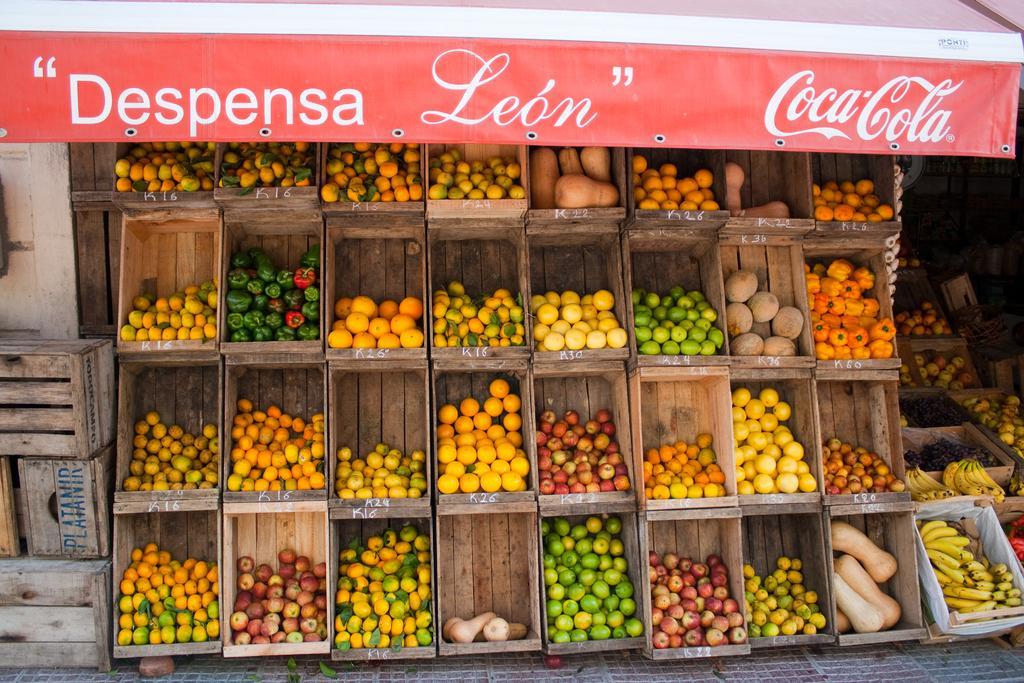Can you describe this image briefly? In this image we can see a fruit store. The fruit boxes are placed one on the other. 